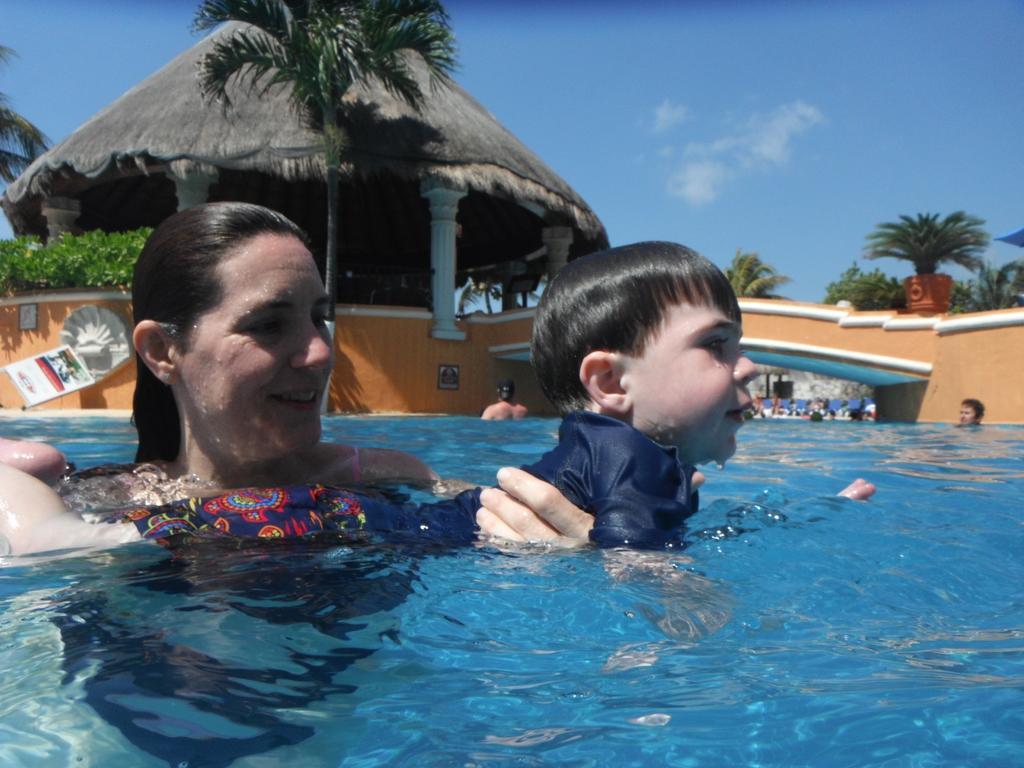Describe this image in one or two sentences. Here I can see a woman is holding a boy in the hands and swimming in the pool. In the background, I can see a wall, some trees and a hut. On the top of the image I can see the sky. 